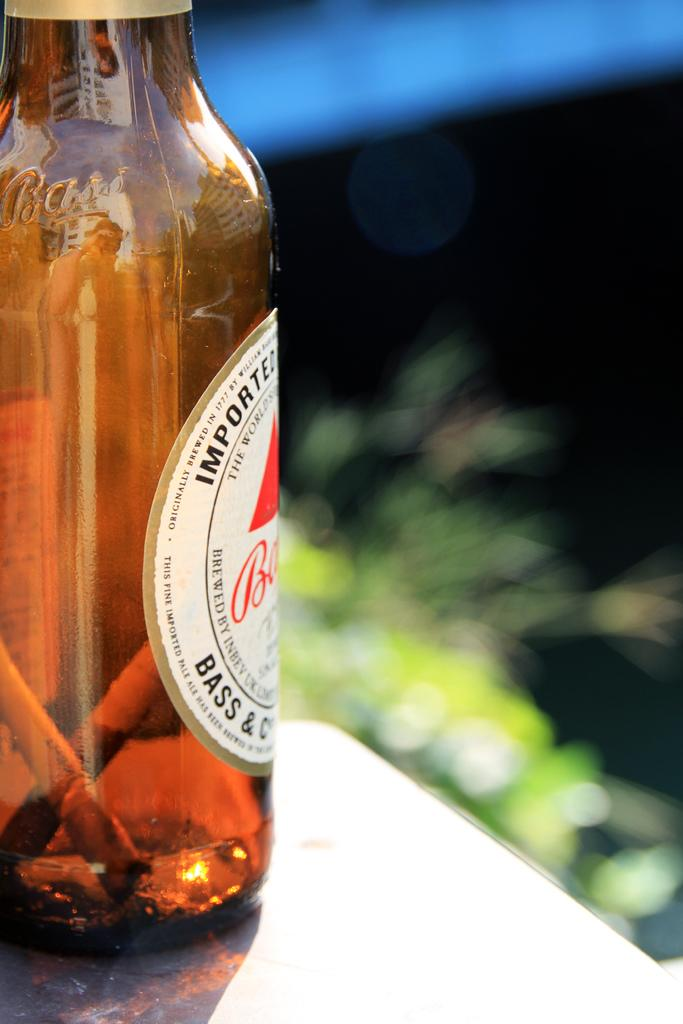<image>
Create a compact narrative representing the image presented. A bottle of imported beer has cigarette butts in it. 